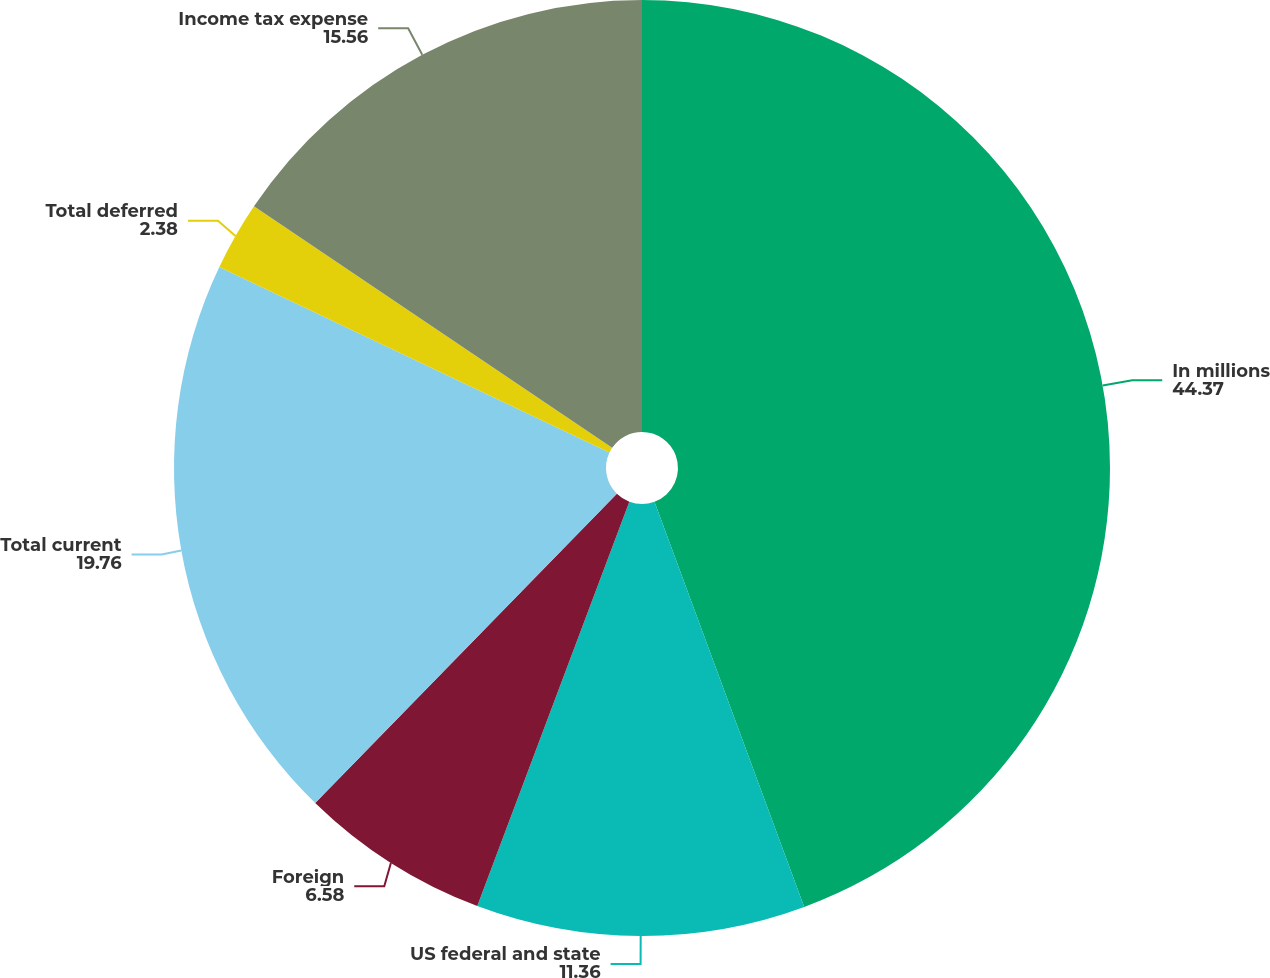Convert chart to OTSL. <chart><loc_0><loc_0><loc_500><loc_500><pie_chart><fcel>In millions<fcel>US federal and state<fcel>Foreign<fcel>Total current<fcel>Total deferred<fcel>Income tax expense<nl><fcel>44.37%<fcel>11.36%<fcel>6.58%<fcel>19.76%<fcel>2.38%<fcel>15.56%<nl></chart> 